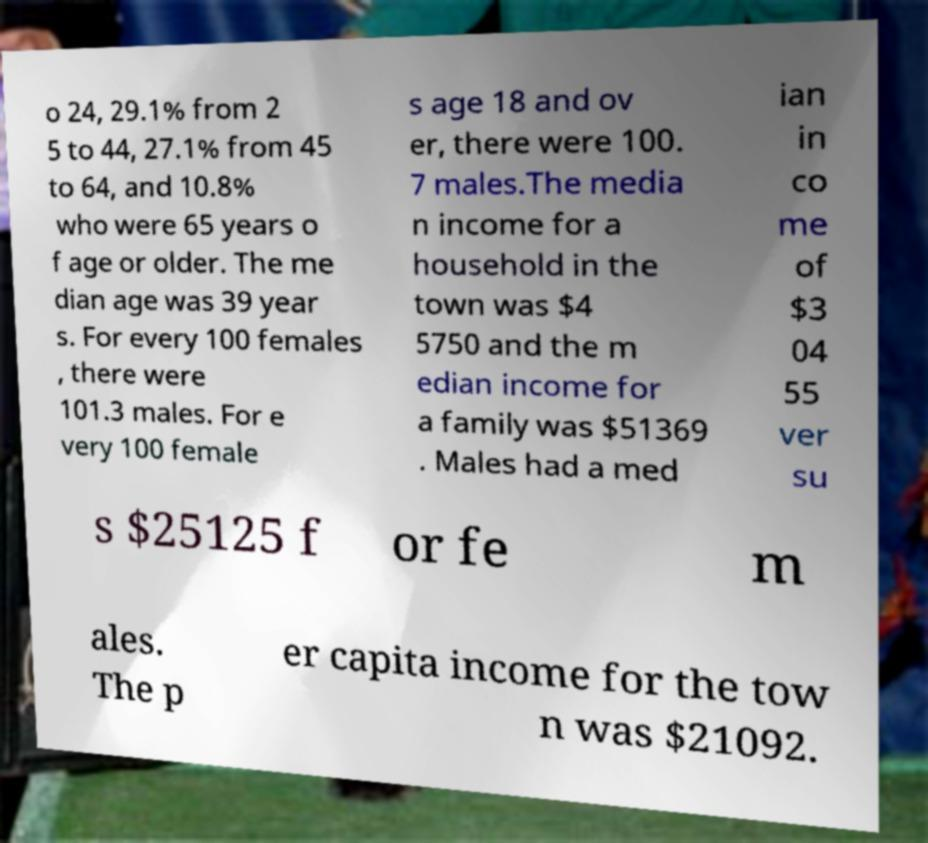Please identify and transcribe the text found in this image. o 24, 29.1% from 2 5 to 44, 27.1% from 45 to 64, and 10.8% who were 65 years o f age or older. The me dian age was 39 year s. For every 100 females , there were 101.3 males. For e very 100 female s age 18 and ov er, there were 100. 7 males.The media n income for a household in the town was $4 5750 and the m edian income for a family was $51369 . Males had a med ian in co me of $3 04 55 ver su s $25125 f or fe m ales. The p er capita income for the tow n was $21092. 